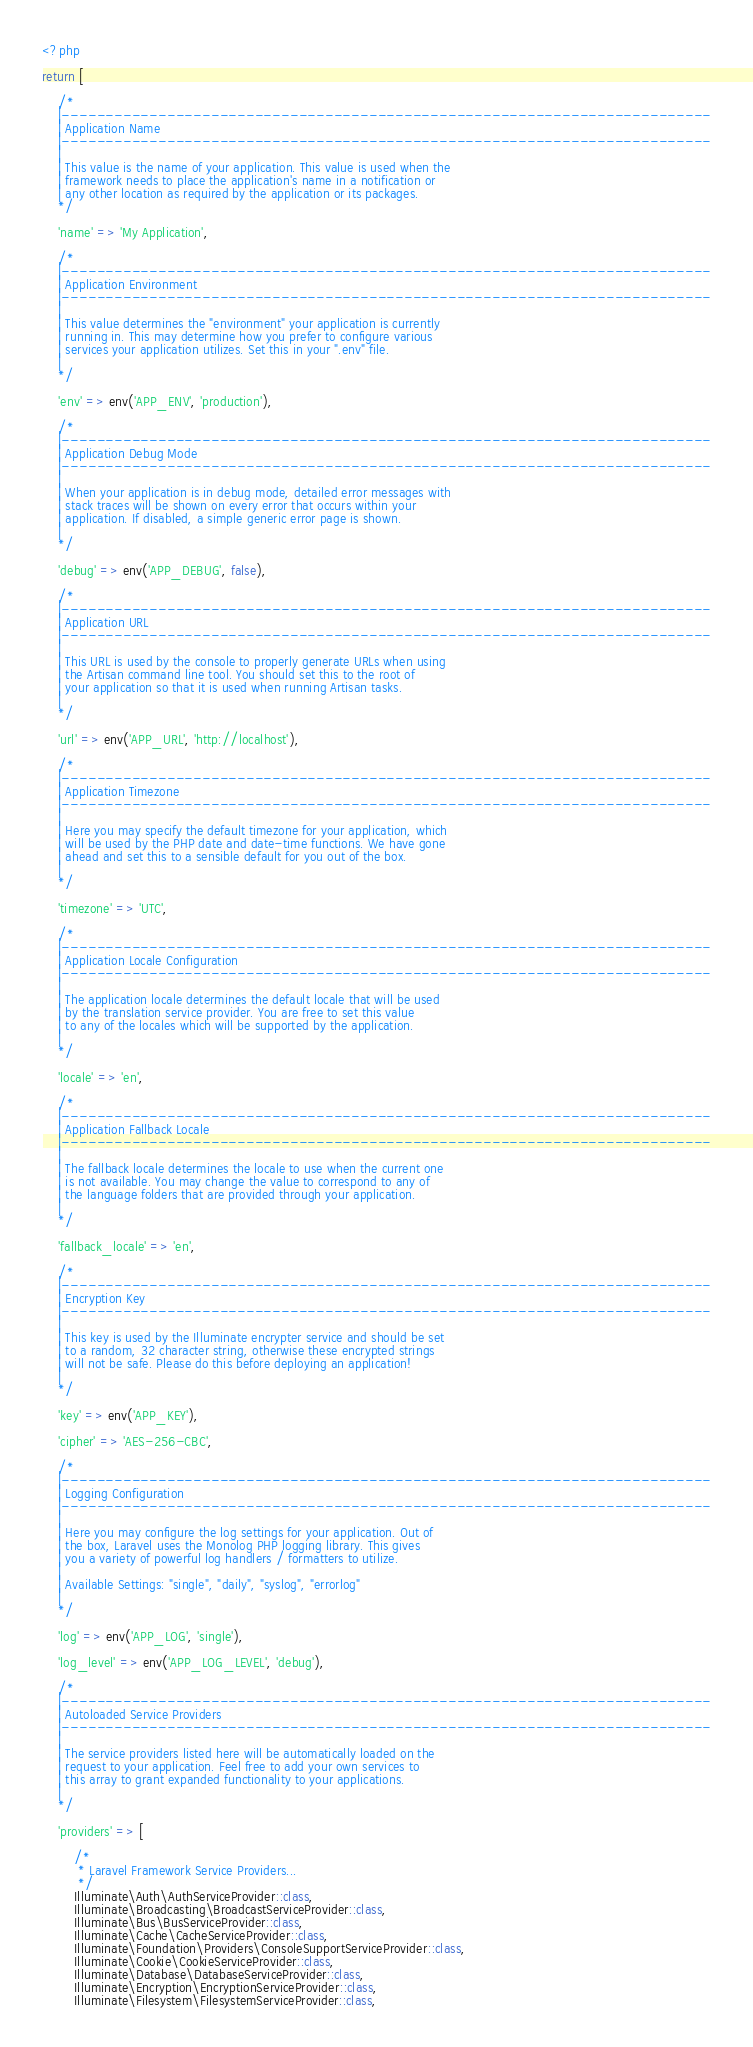<code> <loc_0><loc_0><loc_500><loc_500><_PHP_><?php

return [

    /*
    |--------------------------------------------------------------------------
    | Application Name
    |--------------------------------------------------------------------------
    |
    | This value is the name of your application. This value is used when the
    | framework needs to place the application's name in a notification or
    | any other location as required by the application or its packages.
    */

    'name' => 'My Application',

    /*
    |--------------------------------------------------------------------------
    | Application Environment
    |--------------------------------------------------------------------------
    |
    | This value determines the "environment" your application is currently
    | running in. This may determine how you prefer to configure various
    | services your application utilizes. Set this in your ".env" file.
    |
    */

    'env' => env('APP_ENV', 'production'),

    /*
    |--------------------------------------------------------------------------
    | Application Debug Mode
    |--------------------------------------------------------------------------
    |
    | When your application is in debug mode, detailed error messages with
    | stack traces will be shown on every error that occurs within your
    | application. If disabled, a simple generic error page is shown.
    |
    */

    'debug' => env('APP_DEBUG', false),

    /*
    |--------------------------------------------------------------------------
    | Application URL
    |--------------------------------------------------------------------------
    |
    | This URL is used by the console to properly generate URLs when using
    | the Artisan command line tool. You should set this to the root of
    | your application so that it is used when running Artisan tasks.
    |
    */

    'url' => env('APP_URL', 'http://localhost'),

    /*
    |--------------------------------------------------------------------------
    | Application Timezone
    |--------------------------------------------------------------------------
    |
    | Here you may specify the default timezone for your application, which
    | will be used by the PHP date and date-time functions. We have gone
    | ahead and set this to a sensible default for you out of the box.
    |
    */

    'timezone' => 'UTC',

    /*
    |--------------------------------------------------------------------------
    | Application Locale Configuration
    |--------------------------------------------------------------------------
    |
    | The application locale determines the default locale that will be used
    | by the translation service provider. You are free to set this value
    | to any of the locales which will be supported by the application.
    |
    */

    'locale' => 'en',

    /*
    |--------------------------------------------------------------------------
    | Application Fallback Locale
    |--------------------------------------------------------------------------
    |
    | The fallback locale determines the locale to use when the current one
    | is not available. You may change the value to correspond to any of
    | the language folders that are provided through your application.
    |
    */

    'fallback_locale' => 'en',

    /*
    |--------------------------------------------------------------------------
    | Encryption Key
    |--------------------------------------------------------------------------
    |
    | This key is used by the Illuminate encrypter service and should be set
    | to a random, 32 character string, otherwise these encrypted strings
    | will not be safe. Please do this before deploying an application!
    |
    */

    'key' => env('APP_KEY'),

    'cipher' => 'AES-256-CBC',

    /*
    |--------------------------------------------------------------------------
    | Logging Configuration
    |--------------------------------------------------------------------------
    |
    | Here you may configure the log settings for your application. Out of
    | the box, Laravel uses the Monolog PHP logging library. This gives
    | you a variety of powerful log handlers / formatters to utilize.
    |
    | Available Settings: "single", "daily", "syslog", "errorlog"
    |
    */

    'log' => env('APP_LOG', 'single'),

    'log_level' => env('APP_LOG_LEVEL', 'debug'),

    /*
    |--------------------------------------------------------------------------
    | Autoloaded Service Providers
    |--------------------------------------------------------------------------
    |
    | The service providers listed here will be automatically loaded on the
    | request to your application. Feel free to add your own services to
    | this array to grant expanded functionality to your applications.
    |
    */

    'providers' => [

        /*
         * Laravel Framework Service Providers...
         */
        Illuminate\Auth\AuthServiceProvider::class,
        Illuminate\Broadcasting\BroadcastServiceProvider::class,
        Illuminate\Bus\BusServiceProvider::class,
        Illuminate\Cache\CacheServiceProvider::class,
        Illuminate\Foundation\Providers\ConsoleSupportServiceProvider::class,
        Illuminate\Cookie\CookieServiceProvider::class,
        Illuminate\Database\DatabaseServiceProvider::class,
        Illuminate\Encryption\EncryptionServiceProvider::class,
        Illuminate\Filesystem\FilesystemServiceProvider::class,</code> 